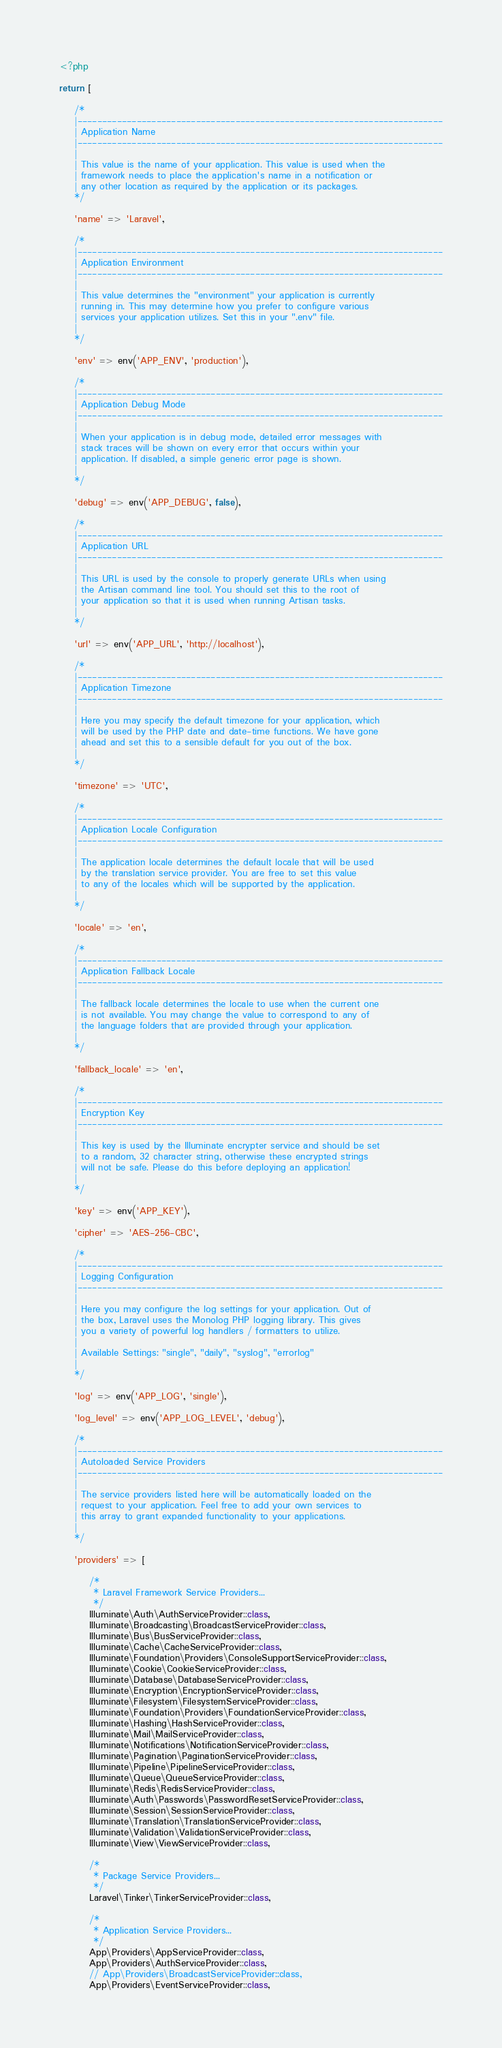<code> <loc_0><loc_0><loc_500><loc_500><_PHP_><?php

return [

    /*
    |--------------------------------------------------------------------------
    | Application Name
    |--------------------------------------------------------------------------
    |
    | This value is the name of your application. This value is used when the
    | framework needs to place the application's name in a notification or
    | any other location as required by the application or its packages.
    */

    'name' => 'Laravel',

    /*
    |--------------------------------------------------------------------------
    | Application Environment
    |--------------------------------------------------------------------------
    |
    | This value determines the "environment" your application is currently
    | running in. This may determine how you prefer to configure various
    | services your application utilizes. Set this in your ".env" file.
    |
    */

    'env' => env('APP_ENV', 'production'),

    /*
    |--------------------------------------------------------------------------
    | Application Debug Mode
    |--------------------------------------------------------------------------
    |
    | When your application is in debug mode, detailed error messages with
    | stack traces will be shown on every error that occurs within your
    | application. If disabled, a simple generic error page is shown.
    |
    */

    'debug' => env('APP_DEBUG', false),

    /*
    |--------------------------------------------------------------------------
    | Application URL
    |--------------------------------------------------------------------------
    |
    | This URL is used by the console to properly generate URLs when using
    | the Artisan command line tool. You should set this to the root of
    | your application so that it is used when running Artisan tasks.
    |
    */

    'url' => env('APP_URL', 'http://localhost'),

    /*
    |--------------------------------------------------------------------------
    | Application Timezone
    |--------------------------------------------------------------------------
    |
    | Here you may specify the default timezone for your application, which
    | will be used by the PHP date and date-time functions. We have gone
    | ahead and set this to a sensible default for you out of the box.
    |
    */

    'timezone' => 'UTC',

    /*
    |--------------------------------------------------------------------------
    | Application Locale Configuration
    |--------------------------------------------------------------------------
    |
    | The application locale determines the default locale that will be used
    | by the translation service provider. You are free to set this value
    | to any of the locales which will be supported by the application.
    |
    */

    'locale' => 'en',

    /*
    |--------------------------------------------------------------------------
    | Application Fallback Locale
    |--------------------------------------------------------------------------
    |
    | The fallback locale determines the locale to use when the current one
    | is not available. You may change the value to correspond to any of
    | the language folders that are provided through your application.
    |
    */

    'fallback_locale' => 'en',

    /*
    |--------------------------------------------------------------------------
    | Encryption Key
    |--------------------------------------------------------------------------
    |
    | This key is used by the Illuminate encrypter service and should be set
    | to a random, 32 character string, otherwise these encrypted strings
    | will not be safe. Please do this before deploying an application!
    |
    */

    'key' => env('APP_KEY'),

    'cipher' => 'AES-256-CBC',

    /*
    |--------------------------------------------------------------------------
    | Logging Configuration
    |--------------------------------------------------------------------------
    |
    | Here you may configure the log settings for your application. Out of
    | the box, Laravel uses the Monolog PHP logging library. This gives
    | you a variety of powerful log handlers / formatters to utilize.
    |
    | Available Settings: "single", "daily", "syslog", "errorlog"
    |
    */

    'log' => env('APP_LOG', 'single'),

    'log_level' => env('APP_LOG_LEVEL', 'debug'),

    /*
    |--------------------------------------------------------------------------
    | Autoloaded Service Providers
    |--------------------------------------------------------------------------
    |
    | The service providers listed here will be automatically loaded on the
    | request to your application. Feel free to add your own services to
    | this array to grant expanded functionality to your applications.
    |
    */

    'providers' => [

        /*
         * Laravel Framework Service Providers...
         */
        Illuminate\Auth\AuthServiceProvider::class,
        Illuminate\Broadcasting\BroadcastServiceProvider::class,
        Illuminate\Bus\BusServiceProvider::class,
        Illuminate\Cache\CacheServiceProvider::class,
        Illuminate\Foundation\Providers\ConsoleSupportServiceProvider::class,
        Illuminate\Cookie\CookieServiceProvider::class,
        Illuminate\Database\DatabaseServiceProvider::class,
        Illuminate\Encryption\EncryptionServiceProvider::class,
        Illuminate\Filesystem\FilesystemServiceProvider::class,
        Illuminate\Foundation\Providers\FoundationServiceProvider::class,
        Illuminate\Hashing\HashServiceProvider::class,
        Illuminate\Mail\MailServiceProvider::class,
        Illuminate\Notifications\NotificationServiceProvider::class,
        Illuminate\Pagination\PaginationServiceProvider::class,
        Illuminate\Pipeline\PipelineServiceProvider::class,
        Illuminate\Queue\QueueServiceProvider::class,
        Illuminate\Redis\RedisServiceProvider::class,
        Illuminate\Auth\Passwords\PasswordResetServiceProvider::class,
        Illuminate\Session\SessionServiceProvider::class,
        Illuminate\Translation\TranslationServiceProvider::class,
        Illuminate\Validation\ValidationServiceProvider::class,
        Illuminate\View\ViewServiceProvider::class,

        /*
         * Package Service Providers...
         */
        Laravel\Tinker\TinkerServiceProvider::class,

        /*
         * Application Service Providers...
         */
        App\Providers\AppServiceProvider::class,
        App\Providers\AuthServiceProvider::class,
        // App\Providers\BroadcastServiceProvider::class,
        App\Providers\EventServiceProvider::class,</code> 